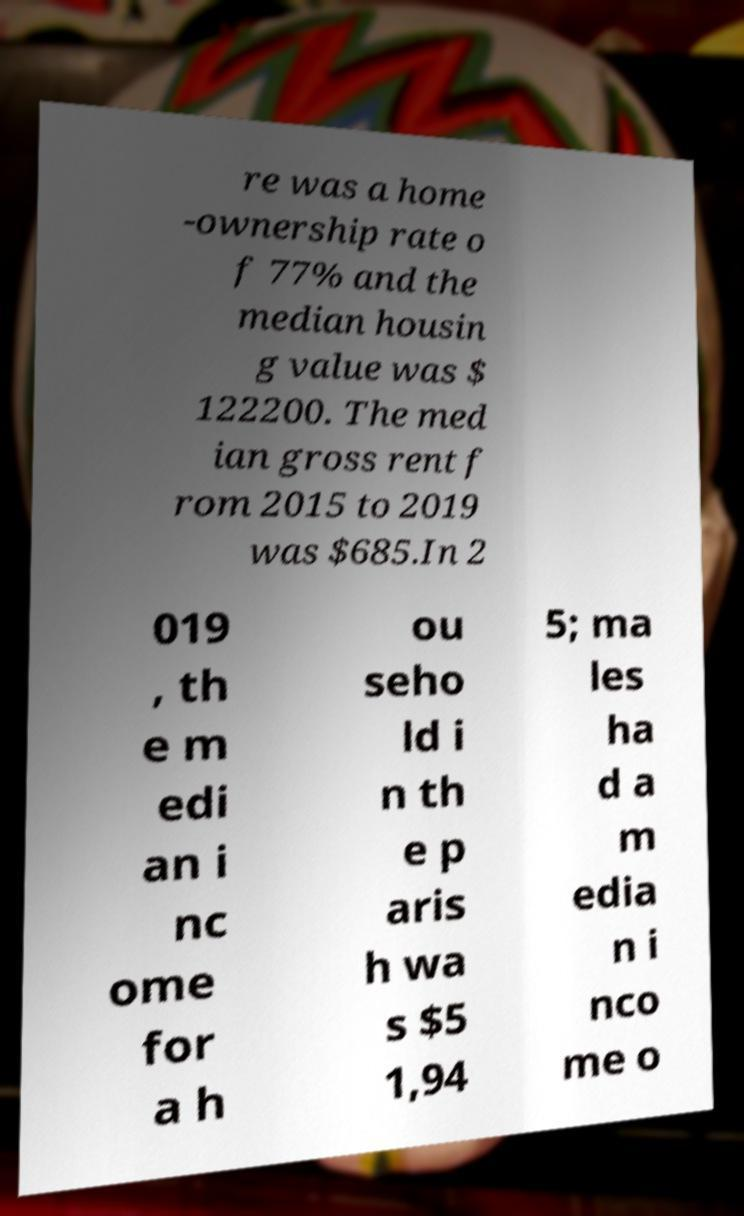There's text embedded in this image that I need extracted. Can you transcribe it verbatim? re was a home -ownership rate o f 77% and the median housin g value was $ 122200. The med ian gross rent f rom 2015 to 2019 was $685.In 2 019 , th e m edi an i nc ome for a h ou seho ld i n th e p aris h wa s $5 1,94 5; ma les ha d a m edia n i nco me o 